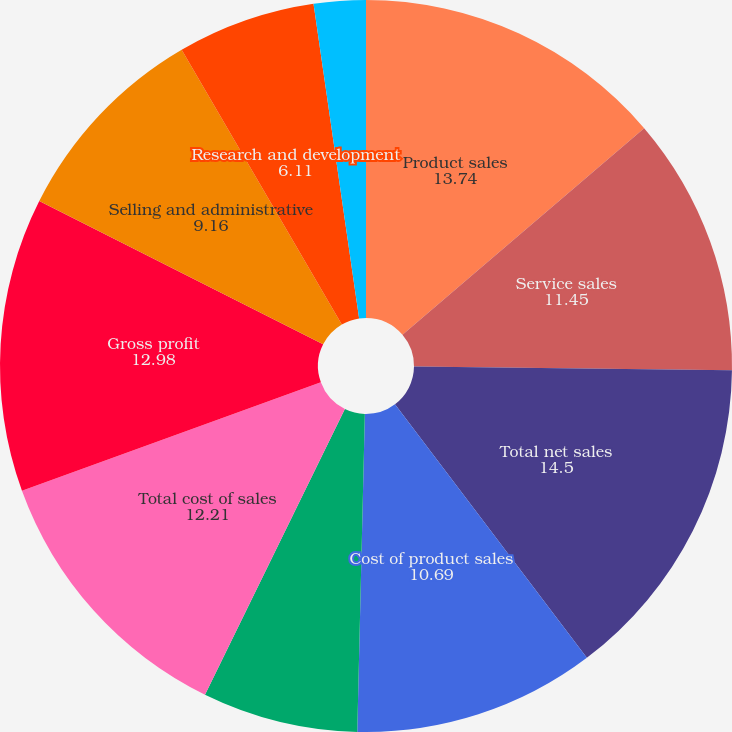<chart> <loc_0><loc_0><loc_500><loc_500><pie_chart><fcel>Product sales<fcel>Service sales<fcel>Total net sales<fcel>Cost of product sales<fcel>Cost of service sales<fcel>Total cost of sales<fcel>Gross profit<fcel>Selling and administrative<fcel>Research and development<fcel>Purchased intangibles<nl><fcel>13.74%<fcel>11.45%<fcel>14.5%<fcel>10.69%<fcel>6.87%<fcel>12.21%<fcel>12.98%<fcel>9.16%<fcel>6.11%<fcel>2.29%<nl></chart> 